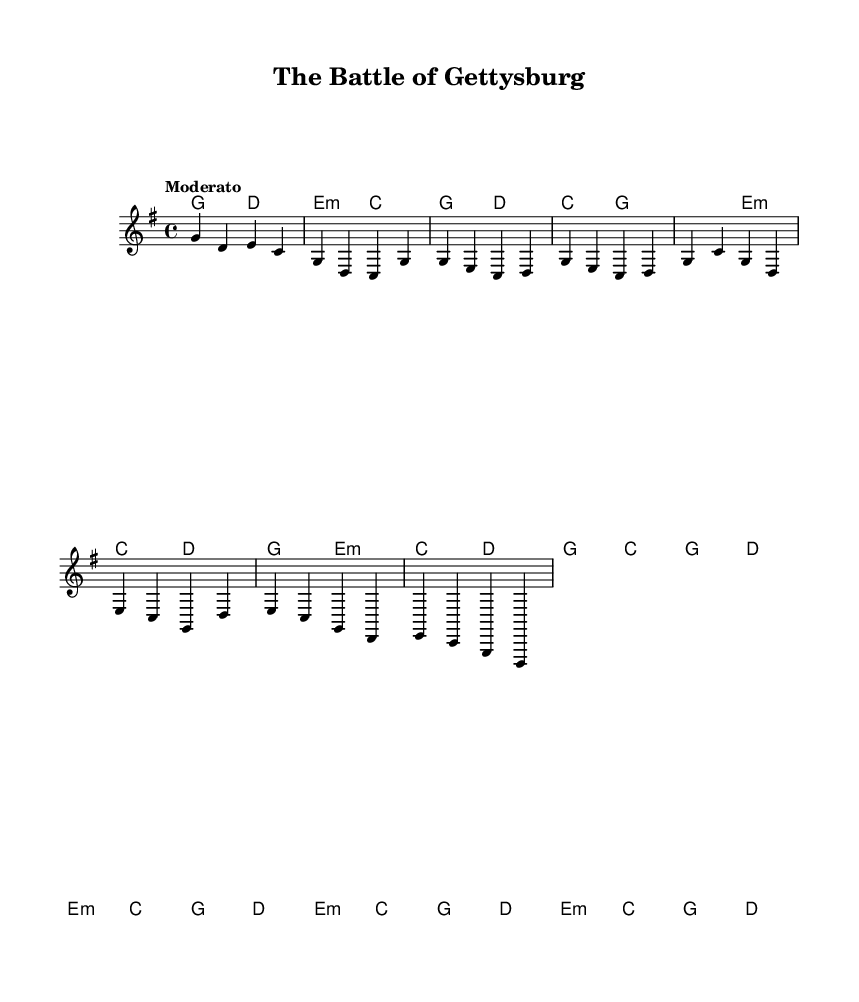What is the key signature of this music? The key signature is indicated by the 'g' in the global block and shows one sharp, which means the music is in G major.
Answer: G major What is the time signature of this piece? The time signature is found next to the \time command, which indicates there are four beats in each measure, represented as 4/4.
Answer: 4/4 What is the tempo marking for this piece? The tempo marking is found within the global block, indicated by the word "Moderato," suggesting a moderate speed.
Answer: Moderato What is the root chord used in the introduction? The root chord of the introduction can be identified in the harmonies section, where the first chord is a G major chord.
Answer: G How many measures are there in the partial chorus section provided? The chorus section consists of two measures shown in the melody and harmonies blocks, which can be counted following the notation.
Answer: 2 What type of song structure is primarily used in this piece? The structure can be identified as a verse-chorus form typical of country ballads, where verses tell a story and choruses express emotion or summary themes.
Answer: Verse-Chorus What specific narrative technique does this song utilize in its storytelling? This piece uses a perspective-driven narrative by presenting multiple views on a historical event, a technique frequently found in storytelling ballads.
Answer: Perspective-driven narrative 